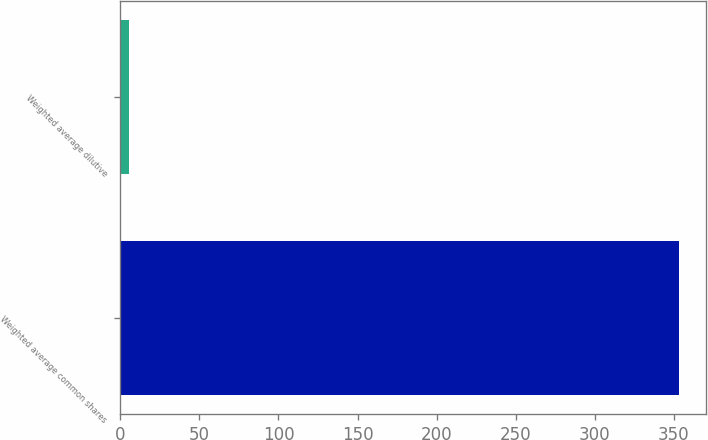Convert chart. <chart><loc_0><loc_0><loc_500><loc_500><bar_chart><fcel>Weighted average common shares<fcel>Weighted average dilutive<nl><fcel>352.99<fcel>5.6<nl></chart> 